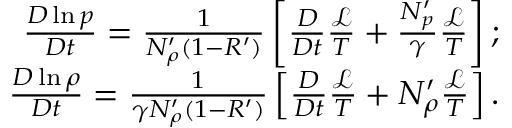<formula> <loc_0><loc_0><loc_500><loc_500>\begin{array} { r } { \frac { D \ln p } { D t } = \frac { 1 } { N _ { \rho } ^ { \prime } ( 1 - R ^ { \prime } ) } \left [ \frac { D } { D t } \frac { \mathcal { L } } { T } + \frac { N _ { p } ^ { \prime } } { \gamma } \frac { \mathcal { L } } { T } \right ] ; } \\ { \frac { D \ln \rho } { D t } = \frac { 1 } { \gamma N _ { \rho } ^ { \prime } ( 1 - R ^ { \prime } ) } \left [ \frac { D } { D t } \frac { \mathcal { L } } { T } + N _ { \rho } ^ { \prime } \frac { \mathcal { L } } { T } \right ] . } \end{array}</formula> 